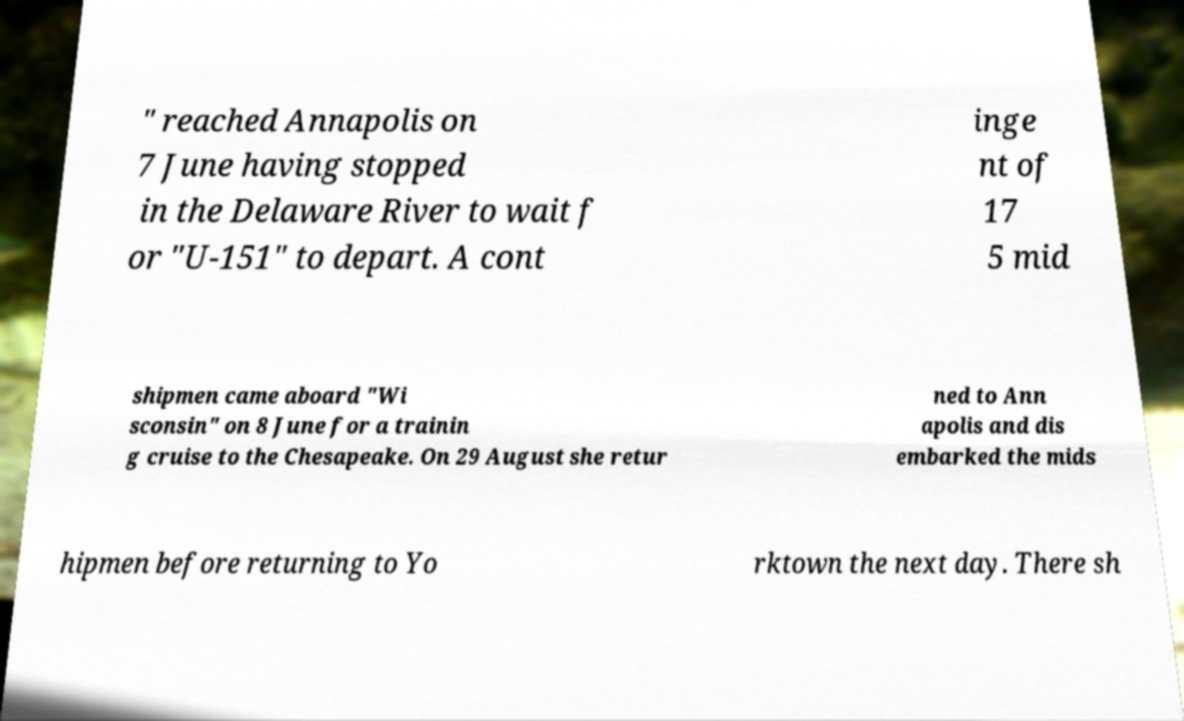Can you read and provide the text displayed in the image?This photo seems to have some interesting text. Can you extract and type it out for me? " reached Annapolis on 7 June having stopped in the Delaware River to wait f or "U-151" to depart. A cont inge nt of 17 5 mid shipmen came aboard "Wi sconsin" on 8 June for a trainin g cruise to the Chesapeake. On 29 August she retur ned to Ann apolis and dis embarked the mids hipmen before returning to Yo rktown the next day. There sh 